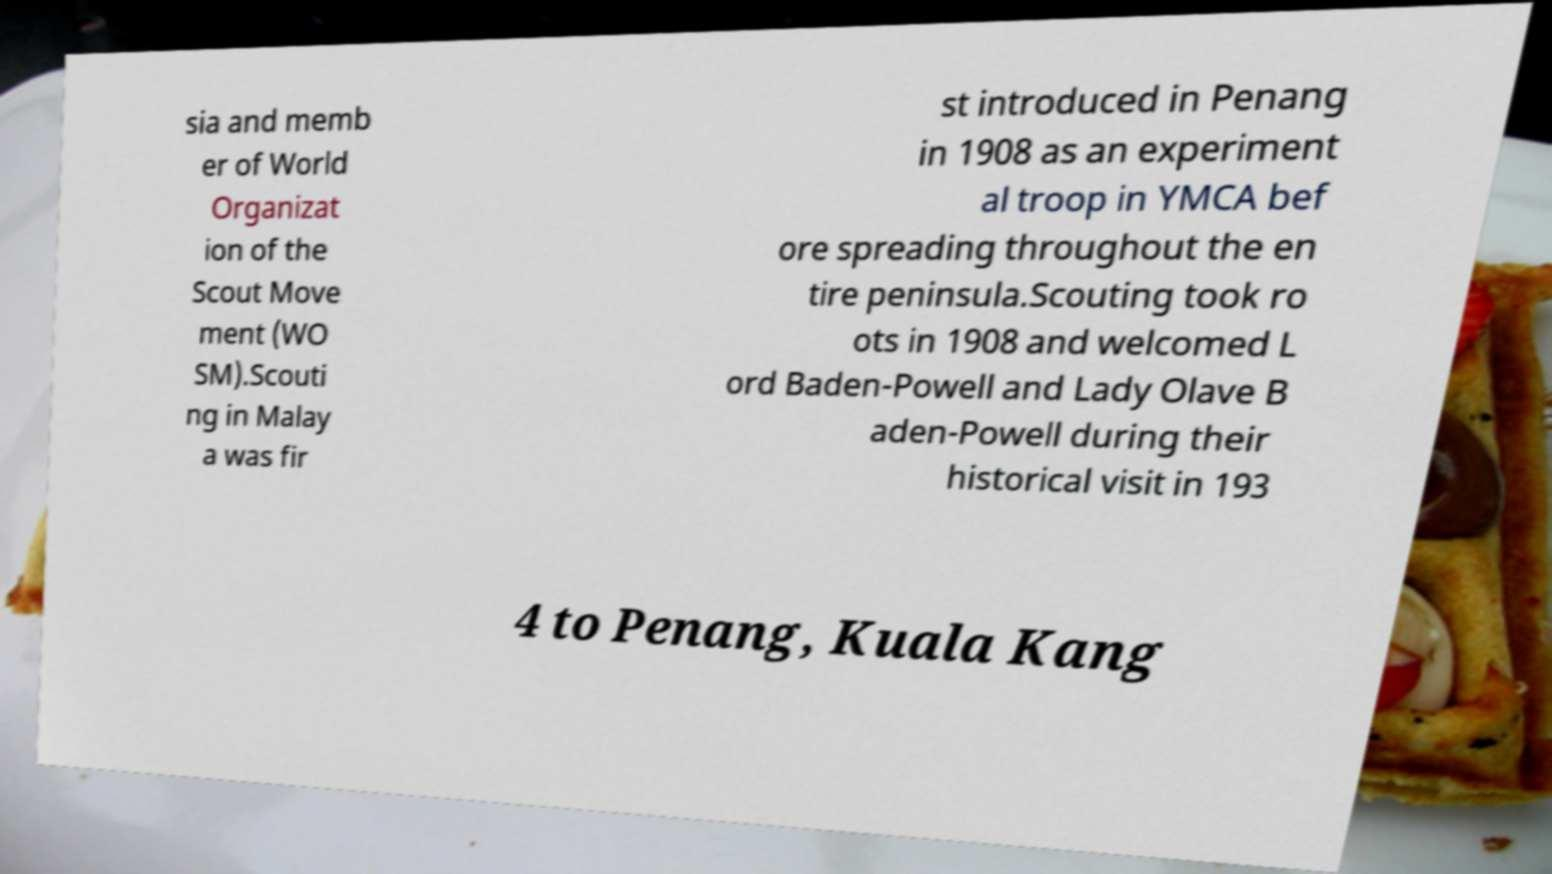What messages or text are displayed in this image? I need them in a readable, typed format. sia and memb er of World Organizat ion of the Scout Move ment (WO SM).Scouti ng in Malay a was fir st introduced in Penang in 1908 as an experiment al troop in YMCA bef ore spreading throughout the en tire peninsula.Scouting took ro ots in 1908 and welcomed L ord Baden-Powell and Lady Olave B aden-Powell during their historical visit in 193 4 to Penang, Kuala Kang 